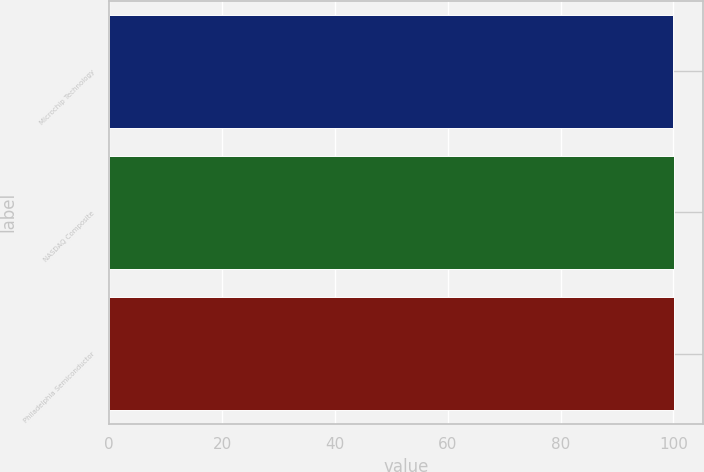<chart> <loc_0><loc_0><loc_500><loc_500><bar_chart><fcel>Microchip Technology<fcel>NASDAQ Composite<fcel>Philadelphia Semiconductor<nl><fcel>100<fcel>100.1<fcel>100.2<nl></chart> 